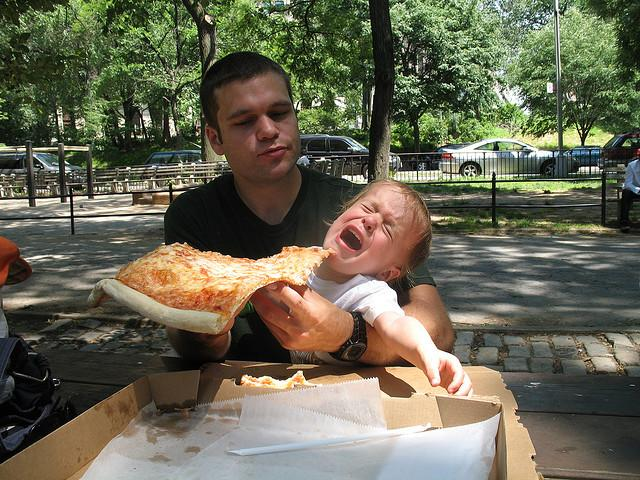What is the most popular pizza cheese? mozzarella 